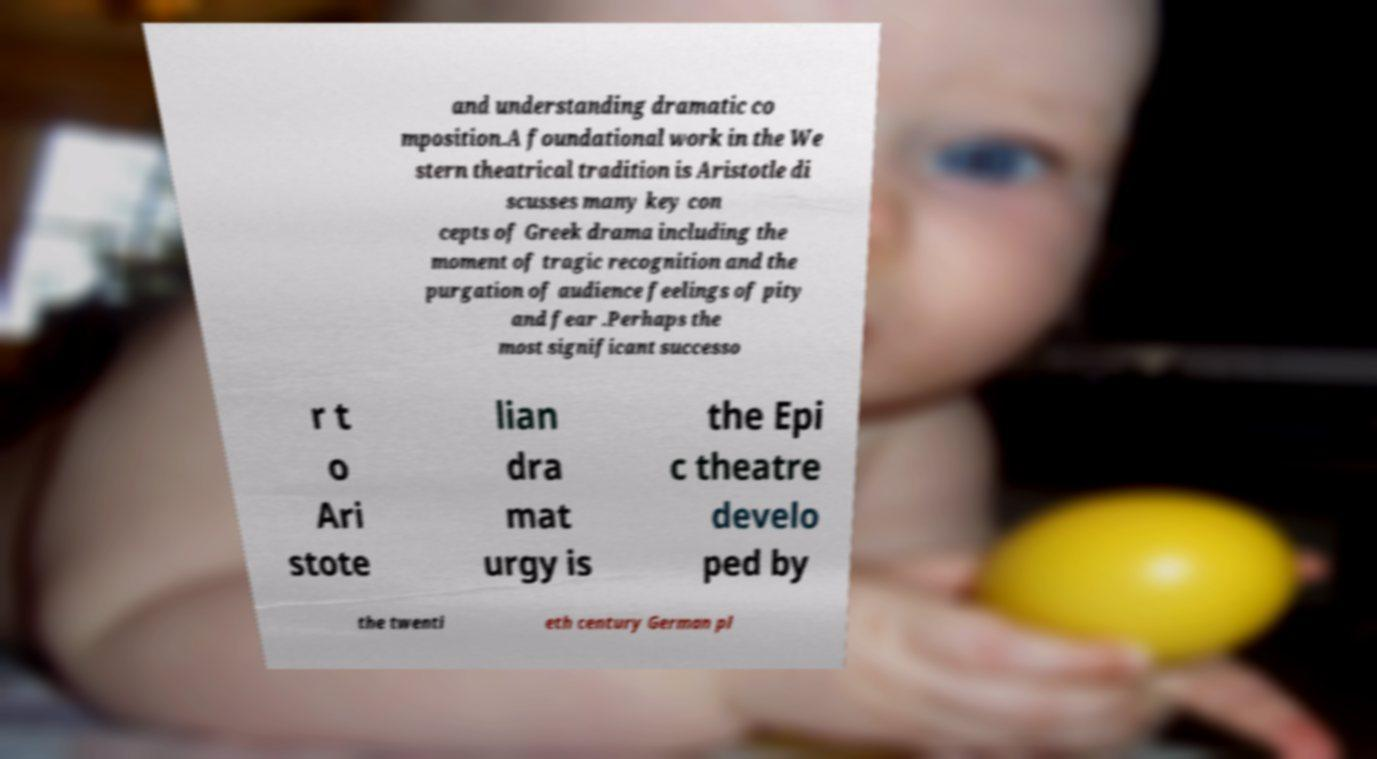Please identify and transcribe the text found in this image. and understanding dramatic co mposition.A foundational work in the We stern theatrical tradition is Aristotle di scusses many key con cepts of Greek drama including the moment of tragic recognition and the purgation of audience feelings of pity and fear .Perhaps the most significant successo r t o Ari stote lian dra mat urgy is the Epi c theatre develo ped by the twenti eth century German pl 